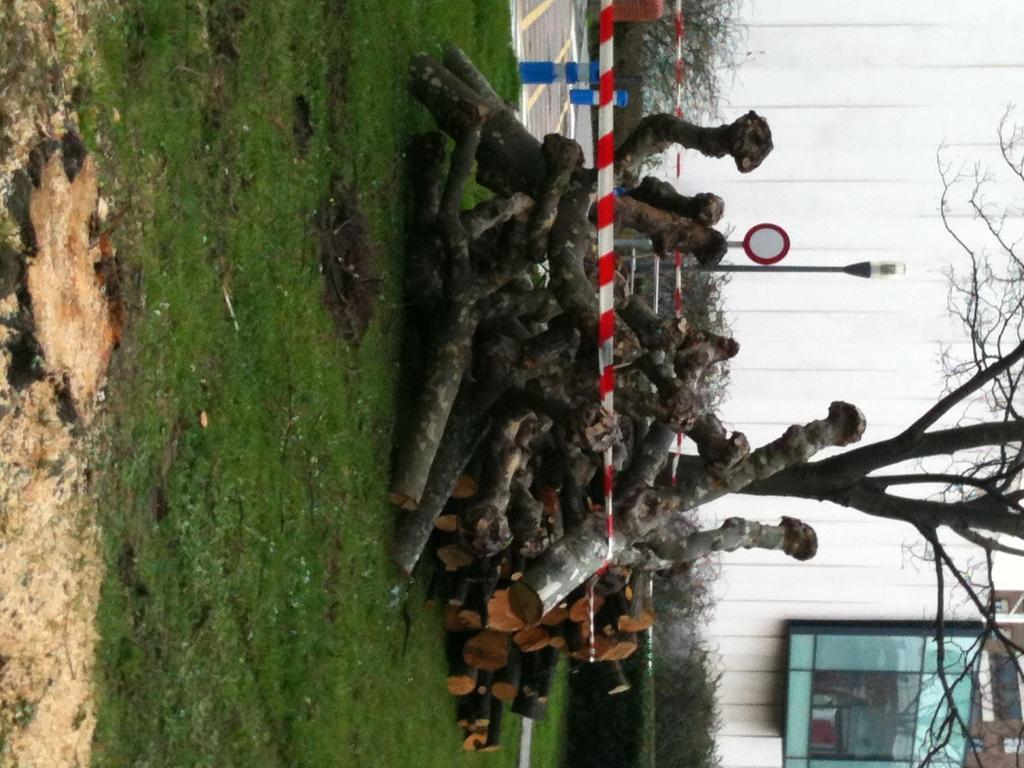In one or two sentences, can you explain what this image depicts? In the center of the image, we can see logs, poles, ribbons, plants and we can see a tree. In the background, there is a board and a wall. At the bottom, there is a road and a ground. 